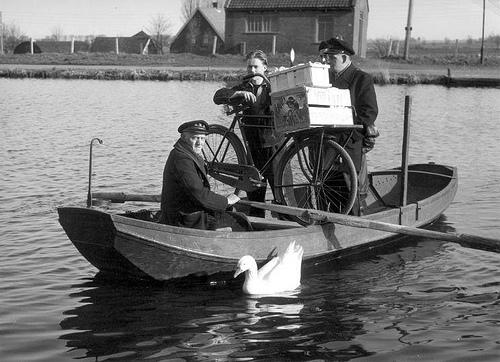Is the picture old?
Be succinct. Yes. Why is a bicycle in the boat?
Give a very brief answer. Crossing river. What is next to the boat?
Give a very brief answer. Swan. 